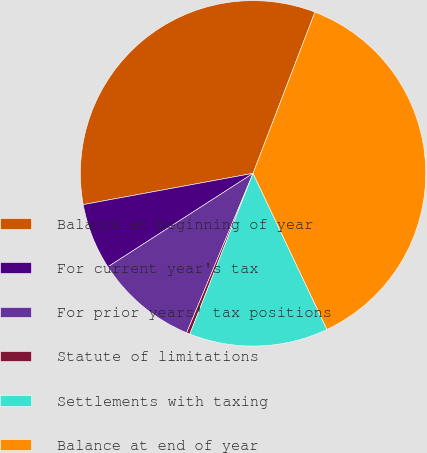<chart> <loc_0><loc_0><loc_500><loc_500><pie_chart><fcel>Balance at beginning of year<fcel>For current year's tax<fcel>For prior years' tax positions<fcel>Statute of limitations<fcel>Settlements with taxing<fcel>Balance at end of year<nl><fcel>33.73%<fcel>6.21%<fcel>9.61%<fcel>0.32%<fcel>13.0%<fcel>37.13%<nl></chart> 